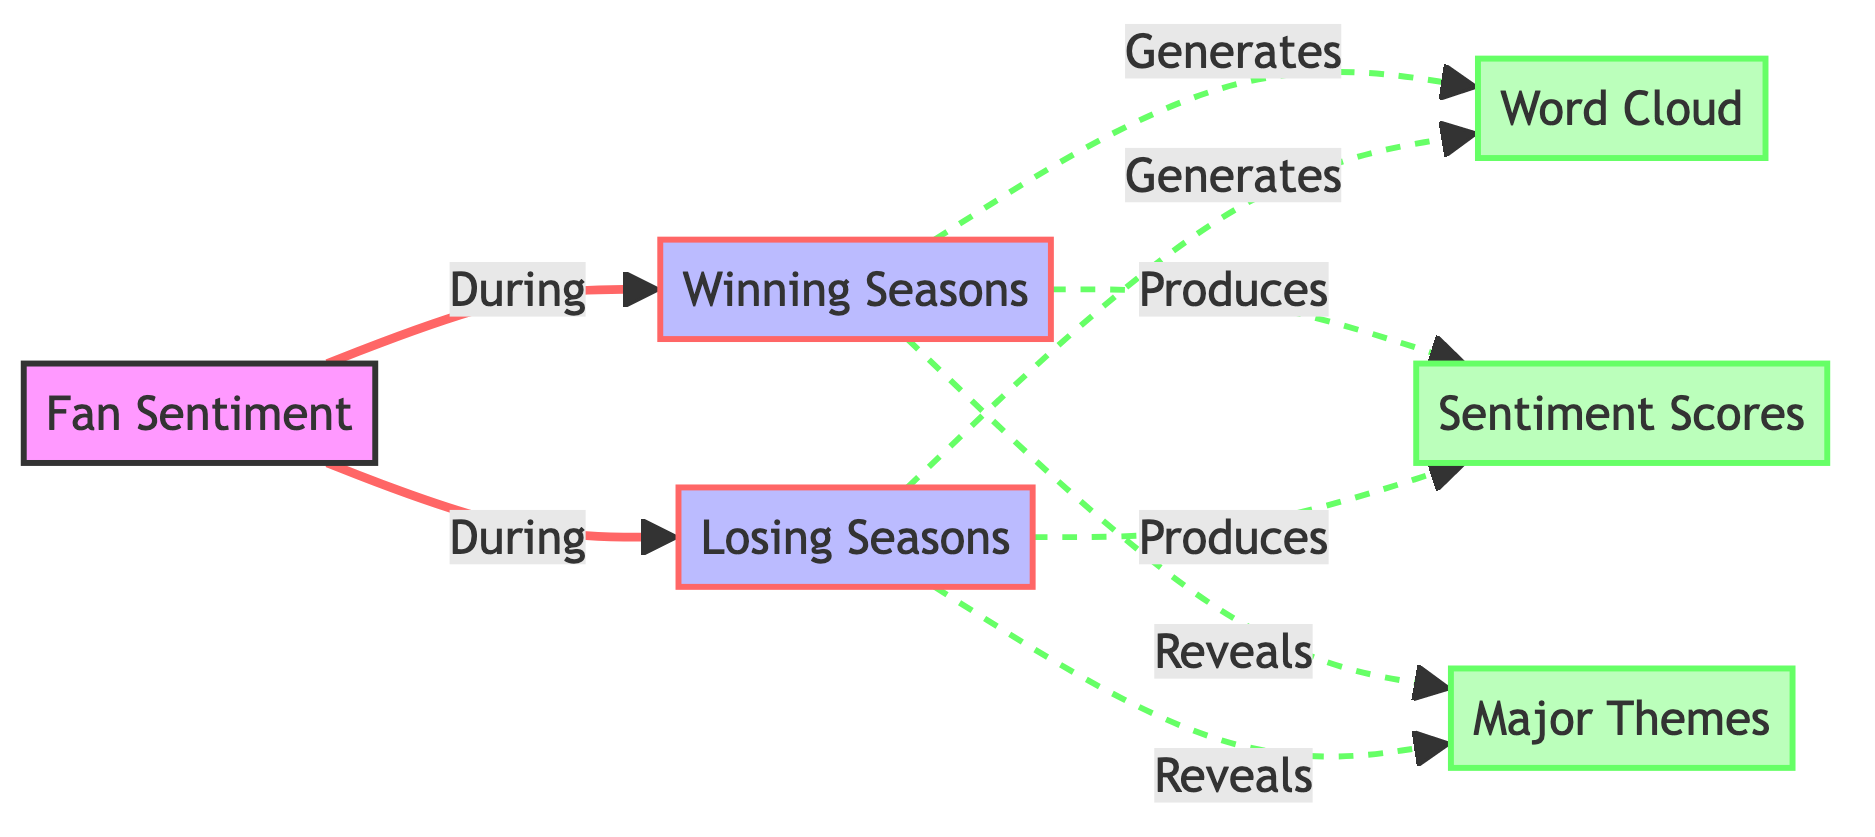what are the two main seasons depicted in this diagram? The diagram highlights two main seasons: winning seasons and losing seasons. They are distinctly mentioned as specific nodes in the flowchart connected to fan sentiment.
Answer: winning seasons, losing seasons which element generates word clouds for both winning and losing seasons? In the diagram, both winning seasons and losing seasons nodes are connected to the word cloud node, indicating they generate word clouds. The arrow connections highlight this relationship.
Answer: word cloud how many types of outputs are produced by winning and losing seasons? Each of winning and losing seasons produces three outputs: a word cloud, sentiment scores, and major themes. The diagram illustrates this with connections from both types of seasons to these outputs.
Answer: three types what is the sentiment score related to in the context of this diagram? The sentiment score is produced in the context of both winning and losing seasons, showing the output of fan sentiment analysis in terms of scores, as indicated by the connections from the seasons to this node.
Answer: fan sentiment analysis which themes are revealed during winning seasons according to the diagram? Winning seasons reveal major themes as indicated in the diagram, where the connection from winning seasons specifically points to the major themes node.
Answer: major themes 